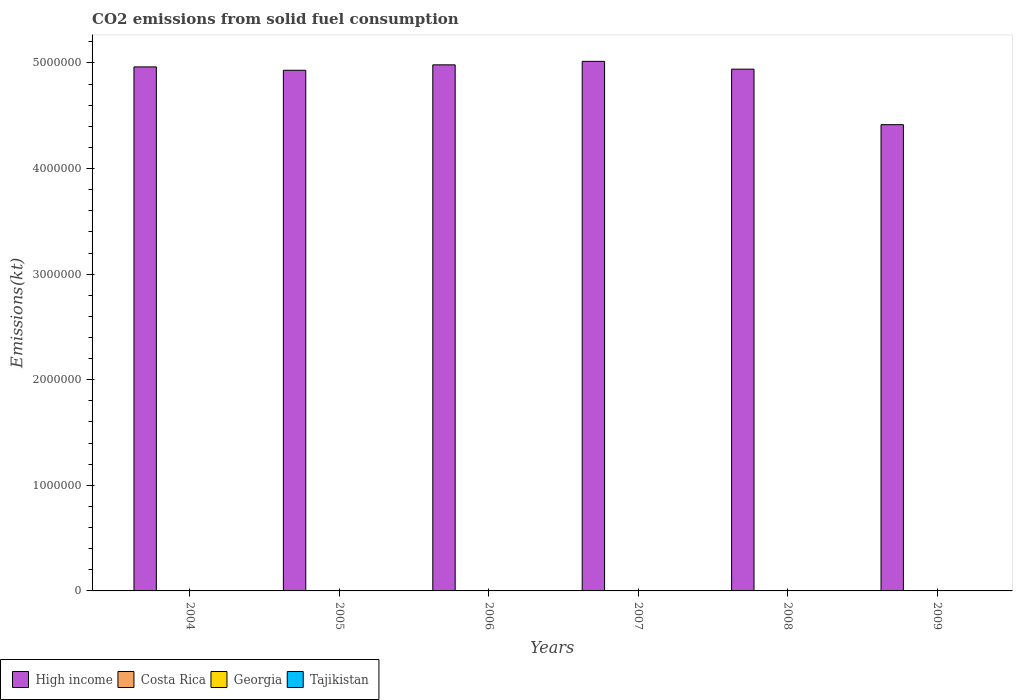How many different coloured bars are there?
Offer a terse response. 4. How many groups of bars are there?
Ensure brevity in your answer.  6. Are the number of bars on each tick of the X-axis equal?
Ensure brevity in your answer.  Yes. How many bars are there on the 5th tick from the left?
Your answer should be very brief. 4. How many bars are there on the 6th tick from the right?
Provide a succinct answer. 4. What is the amount of CO2 emitted in Tajikistan in 2009?
Provide a succinct answer. 297.03. Across all years, what is the maximum amount of CO2 emitted in Tajikistan?
Offer a very short reply. 330.03. Across all years, what is the minimum amount of CO2 emitted in Tajikistan?
Ensure brevity in your answer.  161.35. In which year was the amount of CO2 emitted in Costa Rica minimum?
Your answer should be compact. 2005. What is the total amount of CO2 emitted in High income in the graph?
Ensure brevity in your answer.  2.92e+07. What is the difference between the amount of CO2 emitted in High income in 2006 and that in 2009?
Keep it short and to the point. 5.66e+05. What is the difference between the amount of CO2 emitted in High income in 2007 and the amount of CO2 emitted in Tajikistan in 2004?
Your response must be concise. 5.02e+06. What is the average amount of CO2 emitted in High income per year?
Your response must be concise. 4.87e+06. In the year 2006, what is the difference between the amount of CO2 emitted in Tajikistan and amount of CO2 emitted in Costa Rica?
Offer a very short reply. 29.34. What is the ratio of the amount of CO2 emitted in High income in 2007 to that in 2008?
Your answer should be compact. 1.01. What is the difference between the highest and the second highest amount of CO2 emitted in Tajikistan?
Your answer should be compact. 25.67. What is the difference between the highest and the lowest amount of CO2 emitted in Tajikistan?
Your answer should be compact. 168.68. In how many years, is the amount of CO2 emitted in Tajikistan greater than the average amount of CO2 emitted in Tajikistan taken over all years?
Give a very brief answer. 3. Is it the case that in every year, the sum of the amount of CO2 emitted in High income and amount of CO2 emitted in Tajikistan is greater than the sum of amount of CO2 emitted in Georgia and amount of CO2 emitted in Costa Rica?
Offer a very short reply. Yes. What does the 2nd bar from the left in 2006 represents?
Your answer should be compact. Costa Rica. Is it the case that in every year, the sum of the amount of CO2 emitted in Costa Rica and amount of CO2 emitted in High income is greater than the amount of CO2 emitted in Tajikistan?
Offer a very short reply. Yes. How many years are there in the graph?
Your answer should be compact. 6. What is the difference between two consecutive major ticks on the Y-axis?
Provide a succinct answer. 1.00e+06. Are the values on the major ticks of Y-axis written in scientific E-notation?
Give a very brief answer. No. How many legend labels are there?
Provide a short and direct response. 4. What is the title of the graph?
Your response must be concise. CO2 emissions from solid fuel consumption. Does "Central Europe" appear as one of the legend labels in the graph?
Provide a succinct answer. No. What is the label or title of the X-axis?
Your response must be concise. Years. What is the label or title of the Y-axis?
Make the answer very short. Emissions(kt). What is the Emissions(kt) of High income in 2004?
Keep it short and to the point. 4.96e+06. What is the Emissions(kt) of Costa Rica in 2004?
Provide a succinct answer. 308.03. What is the Emissions(kt) of Georgia in 2004?
Your answer should be very brief. 172.35. What is the Emissions(kt) of Tajikistan in 2004?
Your response must be concise. 161.35. What is the Emissions(kt) in High income in 2005?
Give a very brief answer. 4.93e+06. What is the Emissions(kt) of Costa Rica in 2005?
Make the answer very short. 128.34. What is the Emissions(kt) in Georgia in 2005?
Provide a succinct answer. 179.68. What is the Emissions(kt) in Tajikistan in 2005?
Offer a terse response. 168.68. What is the Emissions(kt) of High income in 2006?
Provide a short and direct response. 4.98e+06. What is the Emissions(kt) in Costa Rica in 2006?
Provide a succinct answer. 146.68. What is the Emissions(kt) of Georgia in 2006?
Make the answer very short. 179.68. What is the Emissions(kt) in Tajikistan in 2006?
Offer a terse response. 176.02. What is the Emissions(kt) of High income in 2007?
Ensure brevity in your answer.  5.02e+06. What is the Emissions(kt) of Costa Rica in 2007?
Offer a terse response. 297.03. What is the Emissions(kt) in Georgia in 2007?
Ensure brevity in your answer.  381.37. What is the Emissions(kt) of Tajikistan in 2007?
Offer a very short reply. 304.36. What is the Emissions(kt) in High income in 2008?
Your answer should be compact. 4.94e+06. What is the Emissions(kt) of Costa Rica in 2008?
Provide a short and direct response. 293.36. What is the Emissions(kt) in Georgia in 2008?
Give a very brief answer. 707.73. What is the Emissions(kt) of Tajikistan in 2008?
Keep it short and to the point. 330.03. What is the Emissions(kt) in High income in 2009?
Make the answer very short. 4.42e+06. What is the Emissions(kt) in Costa Rica in 2009?
Give a very brief answer. 253.02. What is the Emissions(kt) of Georgia in 2009?
Offer a very short reply. 619.72. What is the Emissions(kt) in Tajikistan in 2009?
Provide a succinct answer. 297.03. Across all years, what is the maximum Emissions(kt) in High income?
Your answer should be very brief. 5.02e+06. Across all years, what is the maximum Emissions(kt) in Costa Rica?
Keep it short and to the point. 308.03. Across all years, what is the maximum Emissions(kt) of Georgia?
Make the answer very short. 707.73. Across all years, what is the maximum Emissions(kt) in Tajikistan?
Keep it short and to the point. 330.03. Across all years, what is the minimum Emissions(kt) of High income?
Provide a short and direct response. 4.42e+06. Across all years, what is the minimum Emissions(kt) of Costa Rica?
Your answer should be compact. 128.34. Across all years, what is the minimum Emissions(kt) of Georgia?
Provide a succinct answer. 172.35. Across all years, what is the minimum Emissions(kt) in Tajikistan?
Ensure brevity in your answer.  161.35. What is the total Emissions(kt) in High income in the graph?
Provide a succinct answer. 2.92e+07. What is the total Emissions(kt) of Costa Rica in the graph?
Give a very brief answer. 1426.46. What is the total Emissions(kt) in Georgia in the graph?
Your answer should be very brief. 2240.54. What is the total Emissions(kt) of Tajikistan in the graph?
Make the answer very short. 1437.46. What is the difference between the Emissions(kt) of High income in 2004 and that in 2005?
Your response must be concise. 3.20e+04. What is the difference between the Emissions(kt) in Costa Rica in 2004 and that in 2005?
Provide a succinct answer. 179.68. What is the difference between the Emissions(kt) in Georgia in 2004 and that in 2005?
Keep it short and to the point. -7.33. What is the difference between the Emissions(kt) of Tajikistan in 2004 and that in 2005?
Give a very brief answer. -7.33. What is the difference between the Emissions(kt) of High income in 2004 and that in 2006?
Your response must be concise. -1.95e+04. What is the difference between the Emissions(kt) in Costa Rica in 2004 and that in 2006?
Make the answer very short. 161.35. What is the difference between the Emissions(kt) in Georgia in 2004 and that in 2006?
Your response must be concise. -7.33. What is the difference between the Emissions(kt) of Tajikistan in 2004 and that in 2006?
Provide a short and direct response. -14.67. What is the difference between the Emissions(kt) of High income in 2004 and that in 2007?
Your response must be concise. -5.25e+04. What is the difference between the Emissions(kt) of Costa Rica in 2004 and that in 2007?
Provide a succinct answer. 11. What is the difference between the Emissions(kt) in Georgia in 2004 and that in 2007?
Your response must be concise. -209.02. What is the difference between the Emissions(kt) in Tajikistan in 2004 and that in 2007?
Offer a terse response. -143.01. What is the difference between the Emissions(kt) of High income in 2004 and that in 2008?
Keep it short and to the point. 2.13e+04. What is the difference between the Emissions(kt) in Costa Rica in 2004 and that in 2008?
Provide a short and direct response. 14.67. What is the difference between the Emissions(kt) in Georgia in 2004 and that in 2008?
Keep it short and to the point. -535.38. What is the difference between the Emissions(kt) of Tajikistan in 2004 and that in 2008?
Your answer should be compact. -168.68. What is the difference between the Emissions(kt) of High income in 2004 and that in 2009?
Make the answer very short. 5.47e+05. What is the difference between the Emissions(kt) in Costa Rica in 2004 and that in 2009?
Make the answer very short. 55.01. What is the difference between the Emissions(kt) in Georgia in 2004 and that in 2009?
Provide a short and direct response. -447.37. What is the difference between the Emissions(kt) of Tajikistan in 2004 and that in 2009?
Give a very brief answer. -135.68. What is the difference between the Emissions(kt) of High income in 2005 and that in 2006?
Your response must be concise. -5.15e+04. What is the difference between the Emissions(kt) of Costa Rica in 2005 and that in 2006?
Ensure brevity in your answer.  -18.34. What is the difference between the Emissions(kt) in Georgia in 2005 and that in 2006?
Give a very brief answer. 0. What is the difference between the Emissions(kt) in Tajikistan in 2005 and that in 2006?
Provide a succinct answer. -7.33. What is the difference between the Emissions(kt) in High income in 2005 and that in 2007?
Make the answer very short. -8.45e+04. What is the difference between the Emissions(kt) of Costa Rica in 2005 and that in 2007?
Your answer should be compact. -168.68. What is the difference between the Emissions(kt) in Georgia in 2005 and that in 2007?
Offer a very short reply. -201.69. What is the difference between the Emissions(kt) in Tajikistan in 2005 and that in 2007?
Keep it short and to the point. -135.68. What is the difference between the Emissions(kt) of High income in 2005 and that in 2008?
Provide a short and direct response. -1.07e+04. What is the difference between the Emissions(kt) of Costa Rica in 2005 and that in 2008?
Your answer should be very brief. -165.01. What is the difference between the Emissions(kt) in Georgia in 2005 and that in 2008?
Your response must be concise. -528.05. What is the difference between the Emissions(kt) in Tajikistan in 2005 and that in 2008?
Make the answer very short. -161.35. What is the difference between the Emissions(kt) in High income in 2005 and that in 2009?
Offer a terse response. 5.15e+05. What is the difference between the Emissions(kt) of Costa Rica in 2005 and that in 2009?
Offer a very short reply. -124.68. What is the difference between the Emissions(kt) in Georgia in 2005 and that in 2009?
Make the answer very short. -440.04. What is the difference between the Emissions(kt) of Tajikistan in 2005 and that in 2009?
Provide a short and direct response. -128.34. What is the difference between the Emissions(kt) of High income in 2006 and that in 2007?
Keep it short and to the point. -3.30e+04. What is the difference between the Emissions(kt) of Costa Rica in 2006 and that in 2007?
Your answer should be compact. -150.35. What is the difference between the Emissions(kt) of Georgia in 2006 and that in 2007?
Make the answer very short. -201.69. What is the difference between the Emissions(kt) of Tajikistan in 2006 and that in 2007?
Provide a short and direct response. -128.34. What is the difference between the Emissions(kt) of High income in 2006 and that in 2008?
Provide a succinct answer. 4.08e+04. What is the difference between the Emissions(kt) of Costa Rica in 2006 and that in 2008?
Offer a very short reply. -146.68. What is the difference between the Emissions(kt) of Georgia in 2006 and that in 2008?
Keep it short and to the point. -528.05. What is the difference between the Emissions(kt) in Tajikistan in 2006 and that in 2008?
Your response must be concise. -154.01. What is the difference between the Emissions(kt) in High income in 2006 and that in 2009?
Ensure brevity in your answer.  5.66e+05. What is the difference between the Emissions(kt) in Costa Rica in 2006 and that in 2009?
Offer a very short reply. -106.34. What is the difference between the Emissions(kt) of Georgia in 2006 and that in 2009?
Ensure brevity in your answer.  -440.04. What is the difference between the Emissions(kt) of Tajikistan in 2006 and that in 2009?
Provide a short and direct response. -121.01. What is the difference between the Emissions(kt) of High income in 2007 and that in 2008?
Your answer should be compact. 7.38e+04. What is the difference between the Emissions(kt) in Costa Rica in 2007 and that in 2008?
Offer a terse response. 3.67. What is the difference between the Emissions(kt) in Georgia in 2007 and that in 2008?
Provide a short and direct response. -326.36. What is the difference between the Emissions(kt) of Tajikistan in 2007 and that in 2008?
Offer a terse response. -25.67. What is the difference between the Emissions(kt) of High income in 2007 and that in 2009?
Your answer should be very brief. 6.00e+05. What is the difference between the Emissions(kt) in Costa Rica in 2007 and that in 2009?
Make the answer very short. 44. What is the difference between the Emissions(kt) of Georgia in 2007 and that in 2009?
Provide a succinct answer. -238.35. What is the difference between the Emissions(kt) in Tajikistan in 2007 and that in 2009?
Provide a succinct answer. 7.33. What is the difference between the Emissions(kt) in High income in 2008 and that in 2009?
Your response must be concise. 5.26e+05. What is the difference between the Emissions(kt) of Costa Rica in 2008 and that in 2009?
Keep it short and to the point. 40.34. What is the difference between the Emissions(kt) of Georgia in 2008 and that in 2009?
Give a very brief answer. 88.01. What is the difference between the Emissions(kt) of Tajikistan in 2008 and that in 2009?
Ensure brevity in your answer.  33. What is the difference between the Emissions(kt) in High income in 2004 and the Emissions(kt) in Costa Rica in 2005?
Provide a short and direct response. 4.96e+06. What is the difference between the Emissions(kt) in High income in 2004 and the Emissions(kt) in Georgia in 2005?
Provide a succinct answer. 4.96e+06. What is the difference between the Emissions(kt) of High income in 2004 and the Emissions(kt) of Tajikistan in 2005?
Ensure brevity in your answer.  4.96e+06. What is the difference between the Emissions(kt) of Costa Rica in 2004 and the Emissions(kt) of Georgia in 2005?
Your answer should be compact. 128.34. What is the difference between the Emissions(kt) in Costa Rica in 2004 and the Emissions(kt) in Tajikistan in 2005?
Offer a very short reply. 139.35. What is the difference between the Emissions(kt) of Georgia in 2004 and the Emissions(kt) of Tajikistan in 2005?
Your answer should be compact. 3.67. What is the difference between the Emissions(kt) in High income in 2004 and the Emissions(kt) in Costa Rica in 2006?
Ensure brevity in your answer.  4.96e+06. What is the difference between the Emissions(kt) in High income in 2004 and the Emissions(kt) in Georgia in 2006?
Your answer should be very brief. 4.96e+06. What is the difference between the Emissions(kt) of High income in 2004 and the Emissions(kt) of Tajikistan in 2006?
Your answer should be compact. 4.96e+06. What is the difference between the Emissions(kt) of Costa Rica in 2004 and the Emissions(kt) of Georgia in 2006?
Your answer should be compact. 128.34. What is the difference between the Emissions(kt) in Costa Rica in 2004 and the Emissions(kt) in Tajikistan in 2006?
Your answer should be compact. 132.01. What is the difference between the Emissions(kt) in Georgia in 2004 and the Emissions(kt) in Tajikistan in 2006?
Make the answer very short. -3.67. What is the difference between the Emissions(kt) of High income in 2004 and the Emissions(kt) of Costa Rica in 2007?
Make the answer very short. 4.96e+06. What is the difference between the Emissions(kt) of High income in 2004 and the Emissions(kt) of Georgia in 2007?
Offer a terse response. 4.96e+06. What is the difference between the Emissions(kt) in High income in 2004 and the Emissions(kt) in Tajikistan in 2007?
Provide a short and direct response. 4.96e+06. What is the difference between the Emissions(kt) of Costa Rica in 2004 and the Emissions(kt) of Georgia in 2007?
Your answer should be very brief. -73.34. What is the difference between the Emissions(kt) of Costa Rica in 2004 and the Emissions(kt) of Tajikistan in 2007?
Give a very brief answer. 3.67. What is the difference between the Emissions(kt) of Georgia in 2004 and the Emissions(kt) of Tajikistan in 2007?
Your answer should be compact. -132.01. What is the difference between the Emissions(kt) in High income in 2004 and the Emissions(kt) in Costa Rica in 2008?
Your response must be concise. 4.96e+06. What is the difference between the Emissions(kt) of High income in 2004 and the Emissions(kt) of Georgia in 2008?
Give a very brief answer. 4.96e+06. What is the difference between the Emissions(kt) of High income in 2004 and the Emissions(kt) of Tajikistan in 2008?
Your answer should be very brief. 4.96e+06. What is the difference between the Emissions(kt) of Costa Rica in 2004 and the Emissions(kt) of Georgia in 2008?
Keep it short and to the point. -399.7. What is the difference between the Emissions(kt) in Costa Rica in 2004 and the Emissions(kt) in Tajikistan in 2008?
Provide a succinct answer. -22. What is the difference between the Emissions(kt) in Georgia in 2004 and the Emissions(kt) in Tajikistan in 2008?
Provide a succinct answer. -157.68. What is the difference between the Emissions(kt) of High income in 2004 and the Emissions(kt) of Costa Rica in 2009?
Offer a very short reply. 4.96e+06. What is the difference between the Emissions(kt) of High income in 2004 and the Emissions(kt) of Georgia in 2009?
Your response must be concise. 4.96e+06. What is the difference between the Emissions(kt) of High income in 2004 and the Emissions(kt) of Tajikistan in 2009?
Keep it short and to the point. 4.96e+06. What is the difference between the Emissions(kt) in Costa Rica in 2004 and the Emissions(kt) in Georgia in 2009?
Your response must be concise. -311.69. What is the difference between the Emissions(kt) of Costa Rica in 2004 and the Emissions(kt) of Tajikistan in 2009?
Keep it short and to the point. 11. What is the difference between the Emissions(kt) in Georgia in 2004 and the Emissions(kt) in Tajikistan in 2009?
Keep it short and to the point. -124.68. What is the difference between the Emissions(kt) in High income in 2005 and the Emissions(kt) in Costa Rica in 2006?
Your answer should be very brief. 4.93e+06. What is the difference between the Emissions(kt) in High income in 2005 and the Emissions(kt) in Georgia in 2006?
Make the answer very short. 4.93e+06. What is the difference between the Emissions(kt) of High income in 2005 and the Emissions(kt) of Tajikistan in 2006?
Offer a terse response. 4.93e+06. What is the difference between the Emissions(kt) of Costa Rica in 2005 and the Emissions(kt) of Georgia in 2006?
Give a very brief answer. -51.34. What is the difference between the Emissions(kt) in Costa Rica in 2005 and the Emissions(kt) in Tajikistan in 2006?
Ensure brevity in your answer.  -47.67. What is the difference between the Emissions(kt) of Georgia in 2005 and the Emissions(kt) of Tajikistan in 2006?
Ensure brevity in your answer.  3.67. What is the difference between the Emissions(kt) in High income in 2005 and the Emissions(kt) in Costa Rica in 2007?
Keep it short and to the point. 4.93e+06. What is the difference between the Emissions(kt) in High income in 2005 and the Emissions(kt) in Georgia in 2007?
Provide a short and direct response. 4.93e+06. What is the difference between the Emissions(kt) in High income in 2005 and the Emissions(kt) in Tajikistan in 2007?
Make the answer very short. 4.93e+06. What is the difference between the Emissions(kt) of Costa Rica in 2005 and the Emissions(kt) of Georgia in 2007?
Your answer should be very brief. -253.02. What is the difference between the Emissions(kt) of Costa Rica in 2005 and the Emissions(kt) of Tajikistan in 2007?
Your answer should be compact. -176.02. What is the difference between the Emissions(kt) in Georgia in 2005 and the Emissions(kt) in Tajikistan in 2007?
Offer a very short reply. -124.68. What is the difference between the Emissions(kt) in High income in 2005 and the Emissions(kt) in Costa Rica in 2008?
Make the answer very short. 4.93e+06. What is the difference between the Emissions(kt) in High income in 2005 and the Emissions(kt) in Georgia in 2008?
Your response must be concise. 4.93e+06. What is the difference between the Emissions(kt) of High income in 2005 and the Emissions(kt) of Tajikistan in 2008?
Your answer should be very brief. 4.93e+06. What is the difference between the Emissions(kt) in Costa Rica in 2005 and the Emissions(kt) in Georgia in 2008?
Make the answer very short. -579.39. What is the difference between the Emissions(kt) of Costa Rica in 2005 and the Emissions(kt) of Tajikistan in 2008?
Your answer should be compact. -201.69. What is the difference between the Emissions(kt) of Georgia in 2005 and the Emissions(kt) of Tajikistan in 2008?
Keep it short and to the point. -150.35. What is the difference between the Emissions(kt) in High income in 2005 and the Emissions(kt) in Costa Rica in 2009?
Offer a terse response. 4.93e+06. What is the difference between the Emissions(kt) of High income in 2005 and the Emissions(kt) of Georgia in 2009?
Your response must be concise. 4.93e+06. What is the difference between the Emissions(kt) in High income in 2005 and the Emissions(kt) in Tajikistan in 2009?
Offer a terse response. 4.93e+06. What is the difference between the Emissions(kt) in Costa Rica in 2005 and the Emissions(kt) in Georgia in 2009?
Offer a terse response. -491.38. What is the difference between the Emissions(kt) in Costa Rica in 2005 and the Emissions(kt) in Tajikistan in 2009?
Keep it short and to the point. -168.68. What is the difference between the Emissions(kt) in Georgia in 2005 and the Emissions(kt) in Tajikistan in 2009?
Offer a very short reply. -117.34. What is the difference between the Emissions(kt) of High income in 2006 and the Emissions(kt) of Costa Rica in 2007?
Offer a terse response. 4.98e+06. What is the difference between the Emissions(kt) of High income in 2006 and the Emissions(kt) of Georgia in 2007?
Your response must be concise. 4.98e+06. What is the difference between the Emissions(kt) of High income in 2006 and the Emissions(kt) of Tajikistan in 2007?
Offer a very short reply. 4.98e+06. What is the difference between the Emissions(kt) of Costa Rica in 2006 and the Emissions(kt) of Georgia in 2007?
Offer a terse response. -234.69. What is the difference between the Emissions(kt) of Costa Rica in 2006 and the Emissions(kt) of Tajikistan in 2007?
Your answer should be very brief. -157.68. What is the difference between the Emissions(kt) of Georgia in 2006 and the Emissions(kt) of Tajikistan in 2007?
Your answer should be very brief. -124.68. What is the difference between the Emissions(kt) in High income in 2006 and the Emissions(kt) in Costa Rica in 2008?
Give a very brief answer. 4.98e+06. What is the difference between the Emissions(kt) of High income in 2006 and the Emissions(kt) of Georgia in 2008?
Your response must be concise. 4.98e+06. What is the difference between the Emissions(kt) of High income in 2006 and the Emissions(kt) of Tajikistan in 2008?
Offer a terse response. 4.98e+06. What is the difference between the Emissions(kt) of Costa Rica in 2006 and the Emissions(kt) of Georgia in 2008?
Your response must be concise. -561.05. What is the difference between the Emissions(kt) in Costa Rica in 2006 and the Emissions(kt) in Tajikistan in 2008?
Make the answer very short. -183.35. What is the difference between the Emissions(kt) of Georgia in 2006 and the Emissions(kt) of Tajikistan in 2008?
Offer a very short reply. -150.35. What is the difference between the Emissions(kt) in High income in 2006 and the Emissions(kt) in Costa Rica in 2009?
Your response must be concise. 4.98e+06. What is the difference between the Emissions(kt) in High income in 2006 and the Emissions(kt) in Georgia in 2009?
Provide a short and direct response. 4.98e+06. What is the difference between the Emissions(kt) of High income in 2006 and the Emissions(kt) of Tajikistan in 2009?
Your answer should be compact. 4.98e+06. What is the difference between the Emissions(kt) in Costa Rica in 2006 and the Emissions(kt) in Georgia in 2009?
Offer a terse response. -473.04. What is the difference between the Emissions(kt) in Costa Rica in 2006 and the Emissions(kt) in Tajikistan in 2009?
Offer a very short reply. -150.35. What is the difference between the Emissions(kt) of Georgia in 2006 and the Emissions(kt) of Tajikistan in 2009?
Your answer should be very brief. -117.34. What is the difference between the Emissions(kt) in High income in 2007 and the Emissions(kt) in Costa Rica in 2008?
Your answer should be compact. 5.02e+06. What is the difference between the Emissions(kt) of High income in 2007 and the Emissions(kt) of Georgia in 2008?
Your response must be concise. 5.01e+06. What is the difference between the Emissions(kt) in High income in 2007 and the Emissions(kt) in Tajikistan in 2008?
Provide a succinct answer. 5.02e+06. What is the difference between the Emissions(kt) of Costa Rica in 2007 and the Emissions(kt) of Georgia in 2008?
Offer a very short reply. -410.7. What is the difference between the Emissions(kt) of Costa Rica in 2007 and the Emissions(kt) of Tajikistan in 2008?
Your answer should be compact. -33. What is the difference between the Emissions(kt) of Georgia in 2007 and the Emissions(kt) of Tajikistan in 2008?
Your answer should be very brief. 51.34. What is the difference between the Emissions(kt) of High income in 2007 and the Emissions(kt) of Costa Rica in 2009?
Offer a very short reply. 5.02e+06. What is the difference between the Emissions(kt) in High income in 2007 and the Emissions(kt) in Georgia in 2009?
Your answer should be very brief. 5.01e+06. What is the difference between the Emissions(kt) of High income in 2007 and the Emissions(kt) of Tajikistan in 2009?
Offer a very short reply. 5.02e+06. What is the difference between the Emissions(kt) in Costa Rica in 2007 and the Emissions(kt) in Georgia in 2009?
Make the answer very short. -322.7. What is the difference between the Emissions(kt) in Costa Rica in 2007 and the Emissions(kt) in Tajikistan in 2009?
Make the answer very short. 0. What is the difference between the Emissions(kt) of Georgia in 2007 and the Emissions(kt) of Tajikistan in 2009?
Ensure brevity in your answer.  84.34. What is the difference between the Emissions(kt) of High income in 2008 and the Emissions(kt) of Costa Rica in 2009?
Give a very brief answer. 4.94e+06. What is the difference between the Emissions(kt) of High income in 2008 and the Emissions(kt) of Georgia in 2009?
Make the answer very short. 4.94e+06. What is the difference between the Emissions(kt) in High income in 2008 and the Emissions(kt) in Tajikistan in 2009?
Provide a short and direct response. 4.94e+06. What is the difference between the Emissions(kt) of Costa Rica in 2008 and the Emissions(kt) of Georgia in 2009?
Ensure brevity in your answer.  -326.36. What is the difference between the Emissions(kt) in Costa Rica in 2008 and the Emissions(kt) in Tajikistan in 2009?
Your answer should be very brief. -3.67. What is the difference between the Emissions(kt) in Georgia in 2008 and the Emissions(kt) in Tajikistan in 2009?
Offer a terse response. 410.7. What is the average Emissions(kt) in High income per year?
Provide a succinct answer. 4.87e+06. What is the average Emissions(kt) of Costa Rica per year?
Keep it short and to the point. 237.74. What is the average Emissions(kt) in Georgia per year?
Make the answer very short. 373.42. What is the average Emissions(kt) in Tajikistan per year?
Your answer should be very brief. 239.58. In the year 2004, what is the difference between the Emissions(kt) of High income and Emissions(kt) of Costa Rica?
Ensure brevity in your answer.  4.96e+06. In the year 2004, what is the difference between the Emissions(kt) in High income and Emissions(kt) in Georgia?
Offer a terse response. 4.96e+06. In the year 2004, what is the difference between the Emissions(kt) of High income and Emissions(kt) of Tajikistan?
Offer a terse response. 4.96e+06. In the year 2004, what is the difference between the Emissions(kt) in Costa Rica and Emissions(kt) in Georgia?
Make the answer very short. 135.68. In the year 2004, what is the difference between the Emissions(kt) of Costa Rica and Emissions(kt) of Tajikistan?
Keep it short and to the point. 146.68. In the year 2004, what is the difference between the Emissions(kt) in Georgia and Emissions(kt) in Tajikistan?
Provide a short and direct response. 11. In the year 2005, what is the difference between the Emissions(kt) of High income and Emissions(kt) of Costa Rica?
Your answer should be very brief. 4.93e+06. In the year 2005, what is the difference between the Emissions(kt) of High income and Emissions(kt) of Georgia?
Ensure brevity in your answer.  4.93e+06. In the year 2005, what is the difference between the Emissions(kt) of High income and Emissions(kt) of Tajikistan?
Your answer should be very brief. 4.93e+06. In the year 2005, what is the difference between the Emissions(kt) in Costa Rica and Emissions(kt) in Georgia?
Make the answer very short. -51.34. In the year 2005, what is the difference between the Emissions(kt) in Costa Rica and Emissions(kt) in Tajikistan?
Provide a short and direct response. -40.34. In the year 2005, what is the difference between the Emissions(kt) in Georgia and Emissions(kt) in Tajikistan?
Your answer should be compact. 11. In the year 2006, what is the difference between the Emissions(kt) of High income and Emissions(kt) of Costa Rica?
Provide a short and direct response. 4.98e+06. In the year 2006, what is the difference between the Emissions(kt) of High income and Emissions(kt) of Georgia?
Offer a terse response. 4.98e+06. In the year 2006, what is the difference between the Emissions(kt) of High income and Emissions(kt) of Tajikistan?
Offer a very short reply. 4.98e+06. In the year 2006, what is the difference between the Emissions(kt) of Costa Rica and Emissions(kt) of Georgia?
Keep it short and to the point. -33. In the year 2006, what is the difference between the Emissions(kt) of Costa Rica and Emissions(kt) of Tajikistan?
Make the answer very short. -29.34. In the year 2006, what is the difference between the Emissions(kt) of Georgia and Emissions(kt) of Tajikistan?
Keep it short and to the point. 3.67. In the year 2007, what is the difference between the Emissions(kt) in High income and Emissions(kt) in Costa Rica?
Offer a terse response. 5.02e+06. In the year 2007, what is the difference between the Emissions(kt) of High income and Emissions(kt) of Georgia?
Make the answer very short. 5.01e+06. In the year 2007, what is the difference between the Emissions(kt) of High income and Emissions(kt) of Tajikistan?
Offer a very short reply. 5.02e+06. In the year 2007, what is the difference between the Emissions(kt) in Costa Rica and Emissions(kt) in Georgia?
Provide a succinct answer. -84.34. In the year 2007, what is the difference between the Emissions(kt) in Costa Rica and Emissions(kt) in Tajikistan?
Your answer should be very brief. -7.33. In the year 2007, what is the difference between the Emissions(kt) of Georgia and Emissions(kt) of Tajikistan?
Your answer should be compact. 77.01. In the year 2008, what is the difference between the Emissions(kt) of High income and Emissions(kt) of Costa Rica?
Offer a very short reply. 4.94e+06. In the year 2008, what is the difference between the Emissions(kt) of High income and Emissions(kt) of Georgia?
Offer a terse response. 4.94e+06. In the year 2008, what is the difference between the Emissions(kt) of High income and Emissions(kt) of Tajikistan?
Ensure brevity in your answer.  4.94e+06. In the year 2008, what is the difference between the Emissions(kt) of Costa Rica and Emissions(kt) of Georgia?
Give a very brief answer. -414.37. In the year 2008, what is the difference between the Emissions(kt) in Costa Rica and Emissions(kt) in Tajikistan?
Keep it short and to the point. -36.67. In the year 2008, what is the difference between the Emissions(kt) of Georgia and Emissions(kt) of Tajikistan?
Your answer should be very brief. 377.7. In the year 2009, what is the difference between the Emissions(kt) of High income and Emissions(kt) of Costa Rica?
Give a very brief answer. 4.42e+06. In the year 2009, what is the difference between the Emissions(kt) of High income and Emissions(kt) of Georgia?
Offer a terse response. 4.42e+06. In the year 2009, what is the difference between the Emissions(kt) of High income and Emissions(kt) of Tajikistan?
Your response must be concise. 4.42e+06. In the year 2009, what is the difference between the Emissions(kt) in Costa Rica and Emissions(kt) in Georgia?
Offer a very short reply. -366.7. In the year 2009, what is the difference between the Emissions(kt) of Costa Rica and Emissions(kt) of Tajikistan?
Keep it short and to the point. -44. In the year 2009, what is the difference between the Emissions(kt) of Georgia and Emissions(kt) of Tajikistan?
Ensure brevity in your answer.  322.7. What is the ratio of the Emissions(kt) of Georgia in 2004 to that in 2005?
Offer a very short reply. 0.96. What is the ratio of the Emissions(kt) in Tajikistan in 2004 to that in 2005?
Provide a succinct answer. 0.96. What is the ratio of the Emissions(kt) in Costa Rica in 2004 to that in 2006?
Give a very brief answer. 2.1. What is the ratio of the Emissions(kt) in Georgia in 2004 to that in 2006?
Offer a very short reply. 0.96. What is the ratio of the Emissions(kt) in Georgia in 2004 to that in 2007?
Offer a very short reply. 0.45. What is the ratio of the Emissions(kt) of Tajikistan in 2004 to that in 2007?
Offer a terse response. 0.53. What is the ratio of the Emissions(kt) of Georgia in 2004 to that in 2008?
Your response must be concise. 0.24. What is the ratio of the Emissions(kt) of Tajikistan in 2004 to that in 2008?
Provide a succinct answer. 0.49. What is the ratio of the Emissions(kt) of High income in 2004 to that in 2009?
Provide a succinct answer. 1.12. What is the ratio of the Emissions(kt) of Costa Rica in 2004 to that in 2009?
Offer a terse response. 1.22. What is the ratio of the Emissions(kt) of Georgia in 2004 to that in 2009?
Your response must be concise. 0.28. What is the ratio of the Emissions(kt) in Tajikistan in 2004 to that in 2009?
Provide a short and direct response. 0.54. What is the ratio of the Emissions(kt) in Georgia in 2005 to that in 2006?
Offer a very short reply. 1. What is the ratio of the Emissions(kt) of High income in 2005 to that in 2007?
Make the answer very short. 0.98. What is the ratio of the Emissions(kt) of Costa Rica in 2005 to that in 2007?
Give a very brief answer. 0.43. What is the ratio of the Emissions(kt) in Georgia in 2005 to that in 2007?
Ensure brevity in your answer.  0.47. What is the ratio of the Emissions(kt) in Tajikistan in 2005 to that in 2007?
Give a very brief answer. 0.55. What is the ratio of the Emissions(kt) in High income in 2005 to that in 2008?
Ensure brevity in your answer.  1. What is the ratio of the Emissions(kt) in Costa Rica in 2005 to that in 2008?
Offer a terse response. 0.44. What is the ratio of the Emissions(kt) of Georgia in 2005 to that in 2008?
Ensure brevity in your answer.  0.25. What is the ratio of the Emissions(kt) of Tajikistan in 2005 to that in 2008?
Give a very brief answer. 0.51. What is the ratio of the Emissions(kt) in High income in 2005 to that in 2009?
Offer a terse response. 1.12. What is the ratio of the Emissions(kt) of Costa Rica in 2005 to that in 2009?
Your answer should be very brief. 0.51. What is the ratio of the Emissions(kt) of Georgia in 2005 to that in 2009?
Your answer should be compact. 0.29. What is the ratio of the Emissions(kt) in Tajikistan in 2005 to that in 2009?
Your response must be concise. 0.57. What is the ratio of the Emissions(kt) in Costa Rica in 2006 to that in 2007?
Provide a succinct answer. 0.49. What is the ratio of the Emissions(kt) in Georgia in 2006 to that in 2007?
Give a very brief answer. 0.47. What is the ratio of the Emissions(kt) in Tajikistan in 2006 to that in 2007?
Provide a short and direct response. 0.58. What is the ratio of the Emissions(kt) of High income in 2006 to that in 2008?
Your response must be concise. 1.01. What is the ratio of the Emissions(kt) in Costa Rica in 2006 to that in 2008?
Provide a short and direct response. 0.5. What is the ratio of the Emissions(kt) in Georgia in 2006 to that in 2008?
Offer a very short reply. 0.25. What is the ratio of the Emissions(kt) of Tajikistan in 2006 to that in 2008?
Provide a succinct answer. 0.53. What is the ratio of the Emissions(kt) in High income in 2006 to that in 2009?
Keep it short and to the point. 1.13. What is the ratio of the Emissions(kt) of Costa Rica in 2006 to that in 2009?
Your response must be concise. 0.58. What is the ratio of the Emissions(kt) in Georgia in 2006 to that in 2009?
Your answer should be very brief. 0.29. What is the ratio of the Emissions(kt) in Tajikistan in 2006 to that in 2009?
Your answer should be compact. 0.59. What is the ratio of the Emissions(kt) in High income in 2007 to that in 2008?
Give a very brief answer. 1.01. What is the ratio of the Emissions(kt) in Costa Rica in 2007 to that in 2008?
Make the answer very short. 1.01. What is the ratio of the Emissions(kt) in Georgia in 2007 to that in 2008?
Provide a succinct answer. 0.54. What is the ratio of the Emissions(kt) of Tajikistan in 2007 to that in 2008?
Your response must be concise. 0.92. What is the ratio of the Emissions(kt) of High income in 2007 to that in 2009?
Your answer should be compact. 1.14. What is the ratio of the Emissions(kt) of Costa Rica in 2007 to that in 2009?
Provide a succinct answer. 1.17. What is the ratio of the Emissions(kt) of Georgia in 2007 to that in 2009?
Your answer should be very brief. 0.62. What is the ratio of the Emissions(kt) in Tajikistan in 2007 to that in 2009?
Your answer should be compact. 1.02. What is the ratio of the Emissions(kt) of High income in 2008 to that in 2009?
Provide a succinct answer. 1.12. What is the ratio of the Emissions(kt) in Costa Rica in 2008 to that in 2009?
Ensure brevity in your answer.  1.16. What is the ratio of the Emissions(kt) of Georgia in 2008 to that in 2009?
Offer a terse response. 1.14. What is the difference between the highest and the second highest Emissions(kt) of High income?
Give a very brief answer. 3.30e+04. What is the difference between the highest and the second highest Emissions(kt) in Costa Rica?
Provide a succinct answer. 11. What is the difference between the highest and the second highest Emissions(kt) of Georgia?
Provide a short and direct response. 88.01. What is the difference between the highest and the second highest Emissions(kt) of Tajikistan?
Keep it short and to the point. 25.67. What is the difference between the highest and the lowest Emissions(kt) in High income?
Make the answer very short. 6.00e+05. What is the difference between the highest and the lowest Emissions(kt) of Costa Rica?
Give a very brief answer. 179.68. What is the difference between the highest and the lowest Emissions(kt) of Georgia?
Provide a short and direct response. 535.38. What is the difference between the highest and the lowest Emissions(kt) in Tajikistan?
Provide a short and direct response. 168.68. 